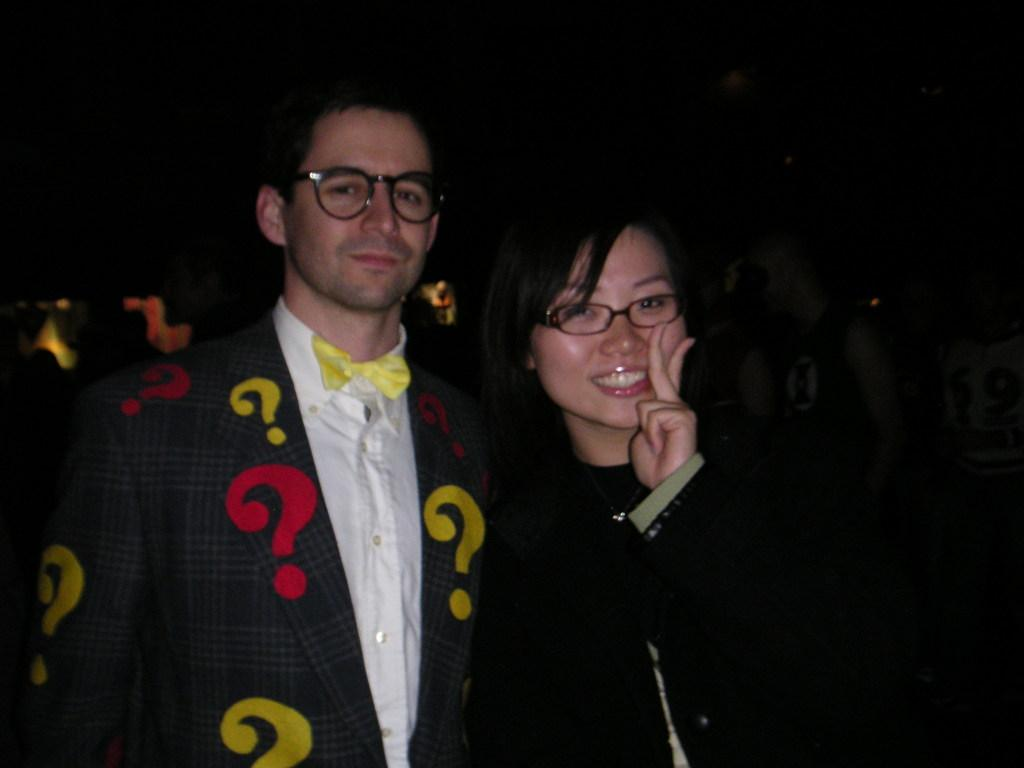How many people are in the image? There are two persons in the image. What do both persons have in common? Both persons are wearing spectacles. What can be said about the background of the image? The background of the image is dark. Can you describe one of the persons in the image? One of the persons is a woman, and she is smiling. What type of wing can be seen on the woman in the image? There is no wing present on the woman in the image. How does the wind affect the appearance of the persons in the image? The image does not show any wind or its effects on the persons. 